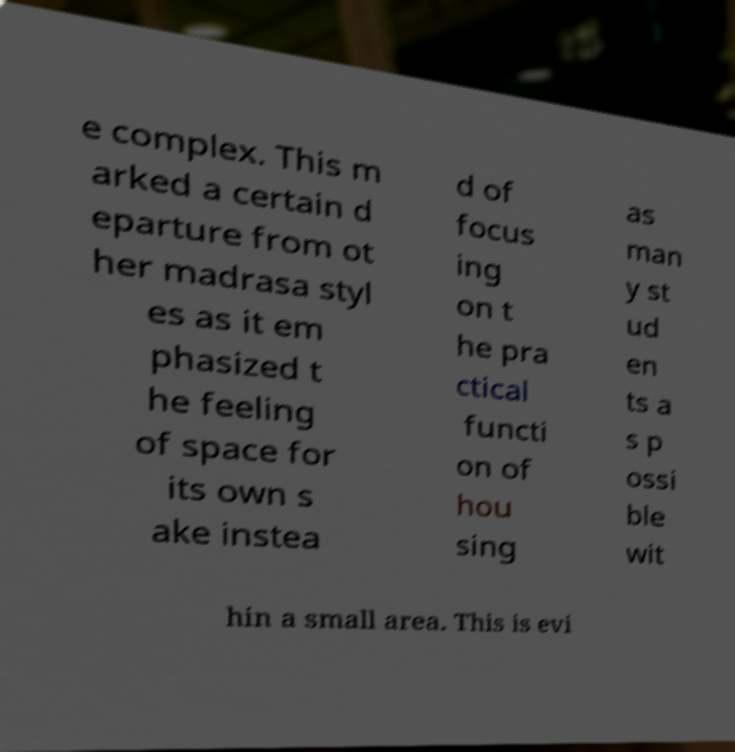Please identify and transcribe the text found in this image. e complex. This m arked a certain d eparture from ot her madrasa styl es as it em phasized t he feeling of space for its own s ake instea d of focus ing on t he pra ctical functi on of hou sing as man y st ud en ts a s p ossi ble wit hin a small area. This is evi 